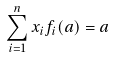Convert formula to latex. <formula><loc_0><loc_0><loc_500><loc_500>\sum _ { i = 1 } ^ { n } x _ { i } f _ { i } ( a ) = a</formula> 